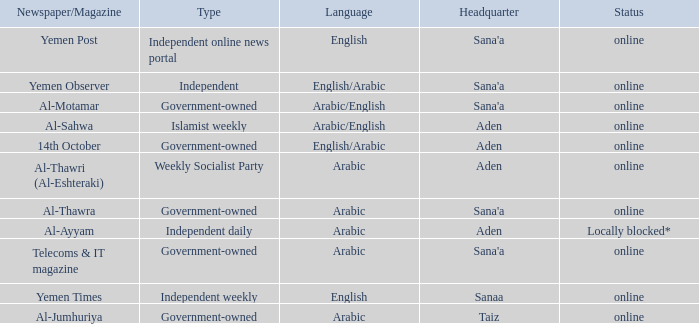What is Headquarter, when Type is Independent Online News Portal? Sana'a. 